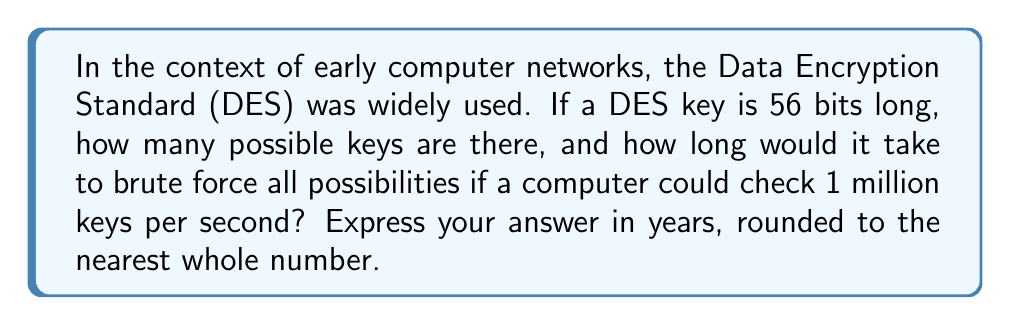Show me your answer to this math problem. To solve this problem, we'll follow these steps:

1. Calculate the number of possible DES keys:
   DES uses a 56-bit key, so the number of possible keys is:
   $$2^{56} = 72,057,594,037,927,936$$

2. Calculate how many keys can be checked per year:
   Keys per second: 1,000,000
   Seconds in a year: 365 * 24 * 60 * 60 = 31,536,000
   Keys per year: $$1,000,000 * 31,536,000 = 31,536,000,000,000$$

3. Calculate how many years it would take to check all keys:
   $$\text{Years} = \frac{\text{Total keys}}{\text{Keys per year}}$$
   $$\text{Years} = \frac{72,057,594,037,927,936}{31,536,000,000,000}$$
   $$\text{Years} = 2,285.57$$

4. Round to the nearest whole number:
   2,286 years

This calculation demonstrates the strength of DES encryption in early computer networks, as it would take an impractical amount of time to brute force all possible keys, even with relatively fast computing power.
Answer: 2,286 years 